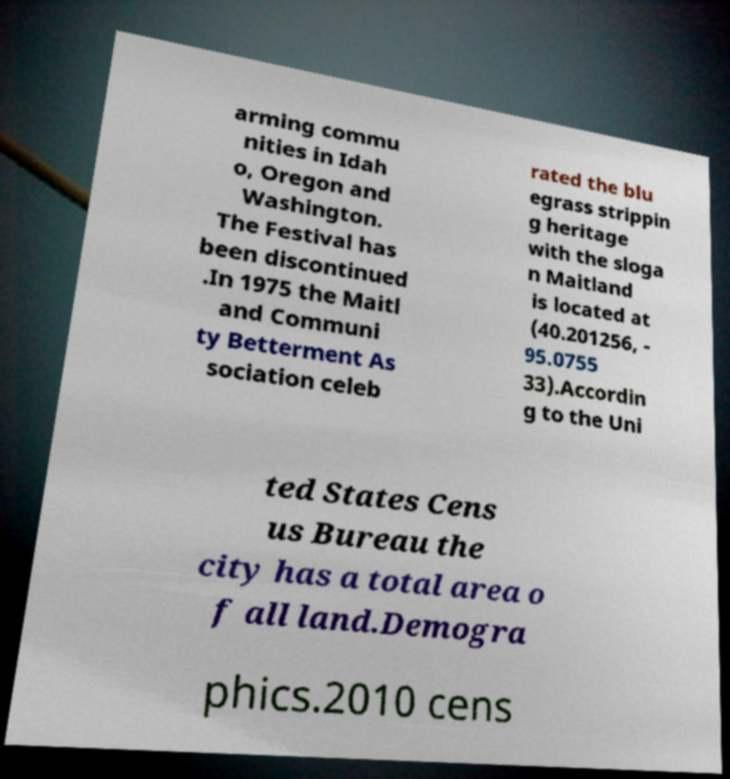I need the written content from this picture converted into text. Can you do that? arming commu nities in Idah o, Oregon and Washington. The Festival has been discontinued .In 1975 the Maitl and Communi ty Betterment As sociation celeb rated the blu egrass strippin g heritage with the sloga n Maitland is located at (40.201256, - 95.0755 33).Accordin g to the Uni ted States Cens us Bureau the city has a total area o f all land.Demogra phics.2010 cens 